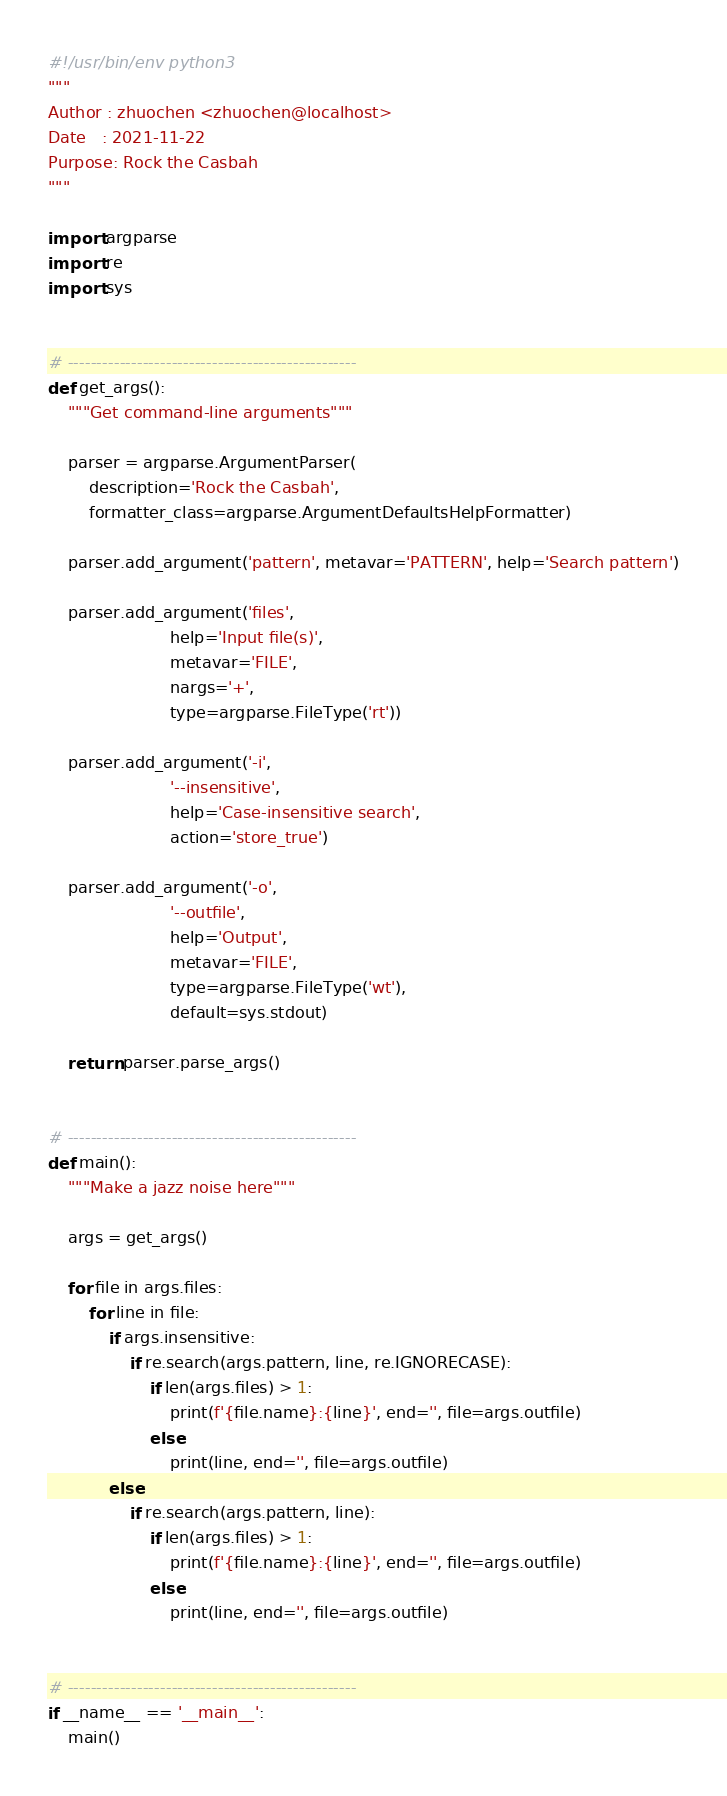<code> <loc_0><loc_0><loc_500><loc_500><_Python_>#!/usr/bin/env python3
"""
Author : zhuochen <zhuochen@localhost>
Date   : 2021-11-22
Purpose: Rock the Casbah
"""

import argparse
import re
import sys


# --------------------------------------------------
def get_args():
    """Get command-line arguments"""

    parser = argparse.ArgumentParser(
        description='Rock the Casbah',
        formatter_class=argparse.ArgumentDefaultsHelpFormatter)

    parser.add_argument('pattern', metavar='PATTERN', help='Search pattern')

    parser.add_argument('files',
                        help='Input file(s)',
                        metavar='FILE',
                        nargs='+',
                        type=argparse.FileType('rt'))

    parser.add_argument('-i',
                        '--insensitive',
                        help='Case-insensitive search',
                        action='store_true')

    parser.add_argument('-o',
                        '--outfile',
                        help='Output',
                        metavar='FILE',
                        type=argparse.FileType('wt'),
                        default=sys.stdout)

    return parser.parse_args()


# --------------------------------------------------
def main():
    """Make a jazz noise here"""

    args = get_args()

    for file in args.files:
        for line in file:
            if args.insensitive:
                if re.search(args.pattern, line, re.IGNORECASE):
                    if len(args.files) > 1:
                        print(f'{file.name}:{line}', end='', file=args.outfile)
                    else:
                        print(line, end='', file=args.outfile)
            else:
                if re.search(args.pattern, line):
                    if len(args.files) > 1:
                        print(f'{file.name}:{line}', end='', file=args.outfile)
                    else:
                        print(line, end='', file=args.outfile)


# --------------------------------------------------
if __name__ == '__main__':
    main()
</code> 